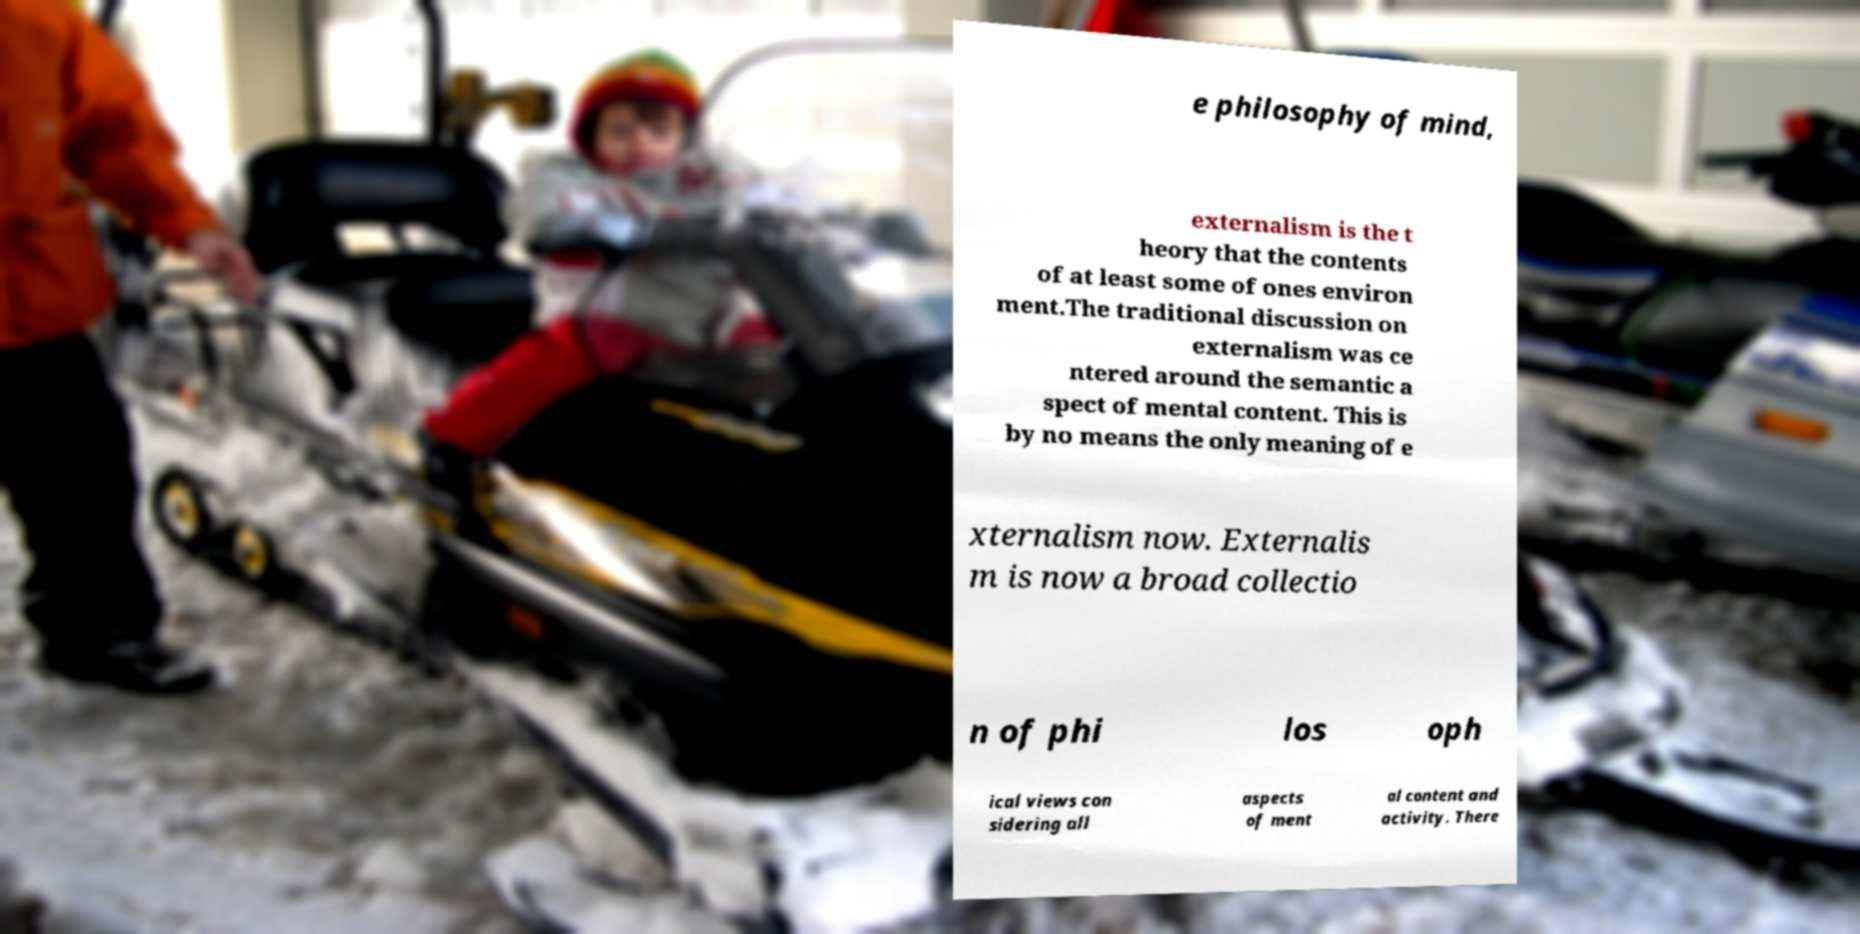For documentation purposes, I need the text within this image transcribed. Could you provide that? e philosophy of mind, externalism is the t heory that the contents of at least some of ones environ ment.The traditional discussion on externalism was ce ntered around the semantic a spect of mental content. This is by no means the only meaning of e xternalism now. Externalis m is now a broad collectio n of phi los oph ical views con sidering all aspects of ment al content and activity. There 